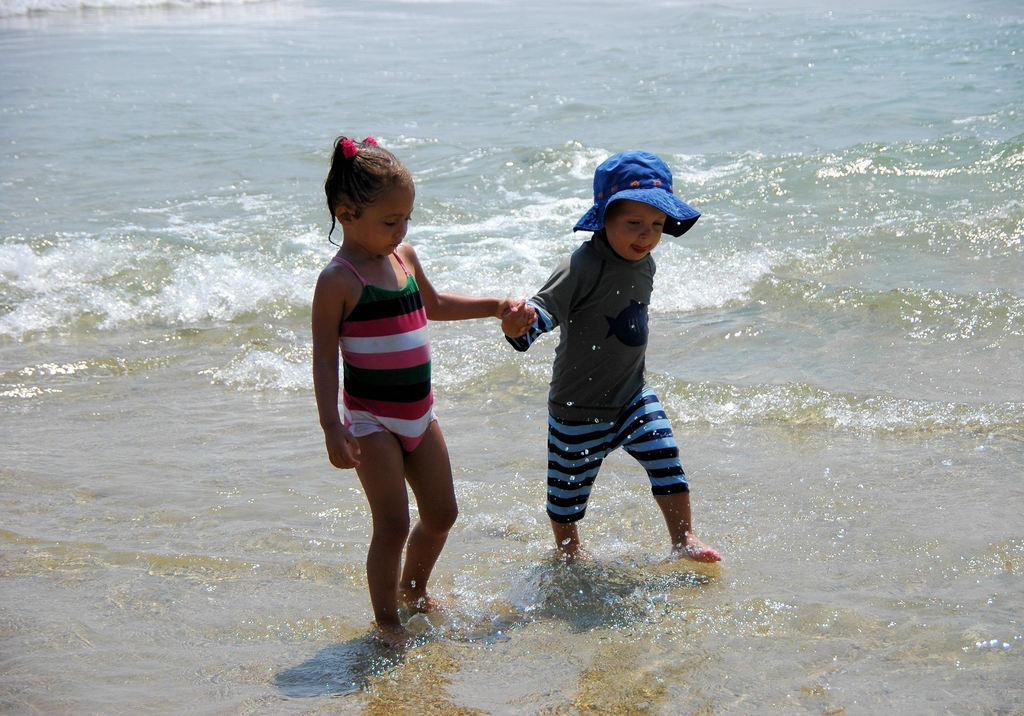How many children are in the image? There are two children in the image. What are the children doing in the image? The children are walking in the water. Can you describe the clothing of one of the children? One of the children is wearing a blue color hat. What can be seen in the background of the image? There is an ocean in the background of the image. What type of juice is being served to the children in the image? There is no juice present in the image; the children are walking in the water. What arithmetic problem are the children solving in the image? There is no arithmetic problem being solved in the image; the children are walking in the water. 